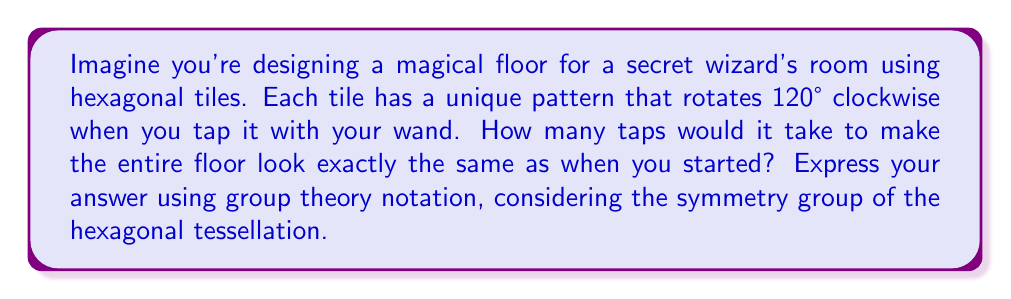Give your solution to this math problem. Let's approach this step-by-step:

1) First, we need to understand the symmetry of a hexagon. A regular hexagon has 6-fold rotational symmetry, meaning it can be rotated by 60°, 120°, 180°, 240°, 300°, and 360° (back to the starting position) to match itself.

2) In this case, each tap rotates the tile by 120° clockwise. This is equivalent to a 240° counterclockwise rotation, which is a 4-fold rotation in group theory notation.

3) The symmetry group of the hexagonal tessellation is the dihedral group $D_6$. This group has 12 elements: 6 rotations and 6 reflections.

4) The rotation we're dealing with here can be represented as $r^4$ in $D_6$, where $r$ represents a 60° rotation.

5) To find how many taps it takes to return to the starting position, we need to find the order of $r^4$ in $D_6$. In group theory, the order of an element is the smallest positive integer $n$ such that $a^n = e$, where $e$ is the identity element.

6) Let's calculate the powers of $r^4$:
   $(r^4)^1 = r^4$
   $(r^4)^2 = r^8 = r^2$
   $(r^4)^3 = r^{12} = r^0 = e$

7) We see that it takes 3 applications of $r^4$ to return to the identity element.

Therefore, it would take 3 taps of your wand to make the entire floor look exactly the same as when you started.
Answer: $|r^4| = 3$ in $D_6$ 